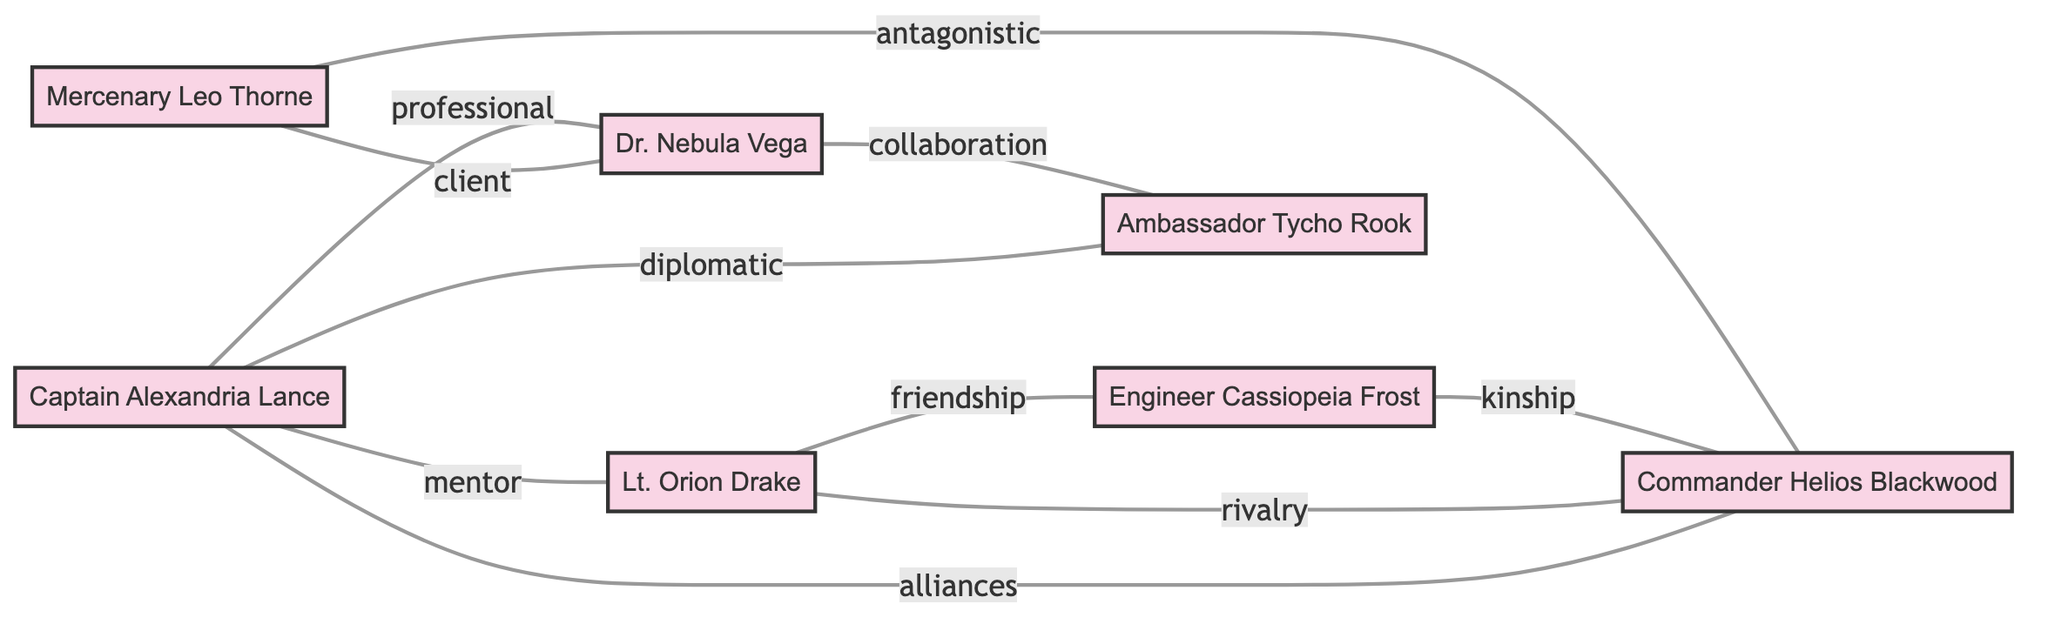What is the total number of characters in the diagram? The diagram lists the nodes representing characters: Captain Alexandria Lance, Dr. Nebula Vega, Lt. Orion Drake, Commander Helios Blackwood, Engineer Cassiopeia Frost, Mercenary Leo Thorne, and Ambassador Tycho Rook. Counting these nodes gives a total of 7 characters.
Answer: 7 What type of relationship exists between Captain Alexandria Lance and Dr. Nebula Vega? The diagram indicates a relationship labeled "professional" connecting Captain Alexandria Lance and Dr. Nebula Vega. Hence, the relationship can be described as professional.
Answer: professional Who is Lt. Orion Drake's mentor? The information in the diagram shows that Captain Alexandria Lance has a "mentor" relationship with Lt. Orion Drake. This means Captain Alexandria Lance serves as the mentor for Lt. Orion Drake.
Answer: Captain Alexandria Lance Which character has an antagonistic relationship with Commander Helios Blackwood? The diagram records a link between Mercenary Leo Thorne and Commander Helios Blackwood, describing their relationship as "antagonistic." Therefore, the character with this relationship is Mercenary Leo Thorne.
Answer: Mercenary Leo Thorne How many alliances are noted in the diagram? By examining the links, there is one specific alliance between Commander Helios Blackwood and Captain Alexandria Lance. Hence, the count of alliances in the diagram is 1.
Answer: 1 Which character is related to Engineer Cassiopeia Frost through kinship? The diagram specifies that Engineer Cassiopeia Frost has a "kinship" link with Commander Helios Blackwood. This indicates that Commander Helios Blackwood is the character related through kinship.
Answer: Commander Helios Blackwood How many types of relationships connect Lt. Orion Drake and Engineer Cassiopeia Frost? By analyzing the diagram, there are two distinct types of relationships stemming from Lt. Orion Drake: one is friendship with Engineer Cassiopeia Frost, and the other is rivalry with Commander Helios Blackwood. However, only the friendship relationship pertains to Engineer Cassiopeia Frost. Thus, there is 1 type of relationship connecting them.
Answer: 1 What is a unique characteristic of this graph regarding the relationships? One unique characteristic of this undirected graph is that it represents various relationship types, such as professional, mentor, friendship, rivalry, alliances, collaboration, client, antagonistic, diplomatic, and kinship, showcasing complex social connections between characters.
Answer: Variety of relationship types 